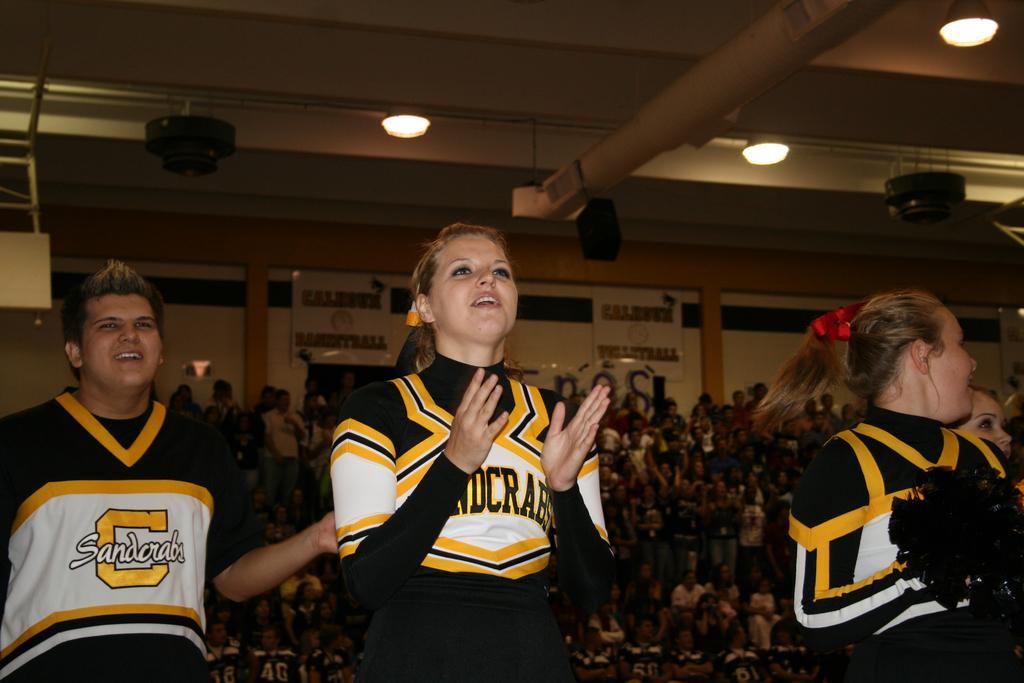How would you summarize this image in a sentence or two? Here we can see three persons. In the background we can see lights, boards, wall, and crowd. 